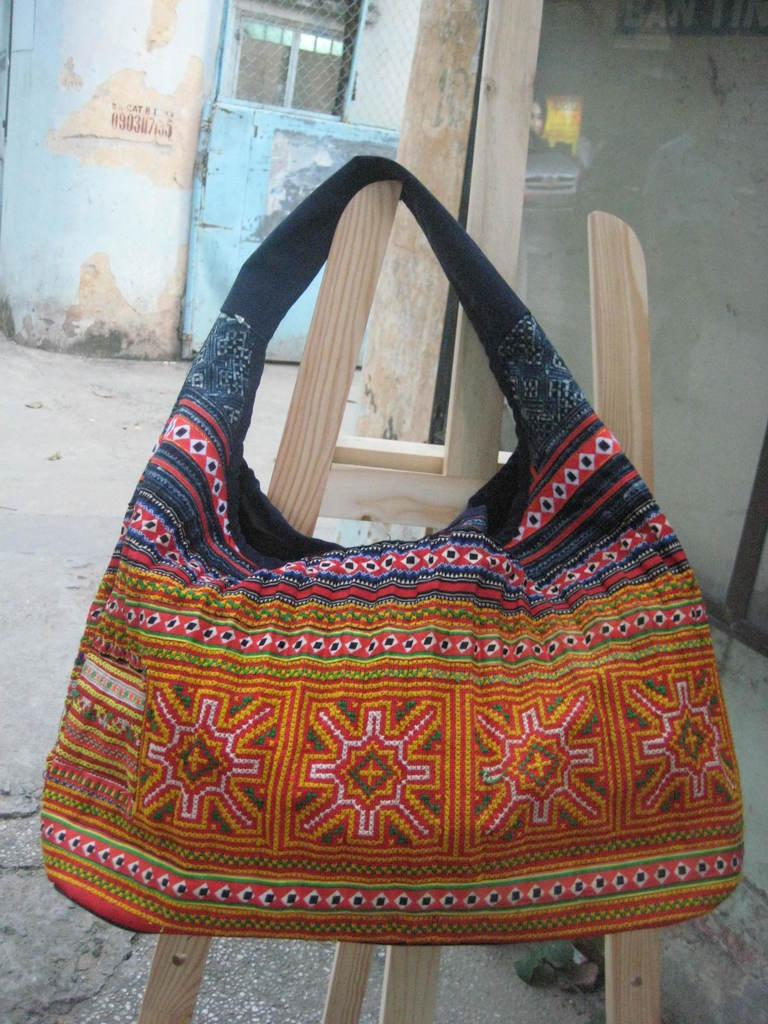What type of handbag is visible in the image? There is a cloth handbag in the image. What design can be seen on the handbag? The handbag has an embroidery design. How is the handbag positioned in the image? The handbag is hanging from a wooden stick. What can be seen in the background of the image? There is a blue color door in the background of the image. What type of cork can be seen on the wooden stick in the image? There is no cork present on the wooden stick in the image; it is simply a wooden stick used to hang the handbag. 